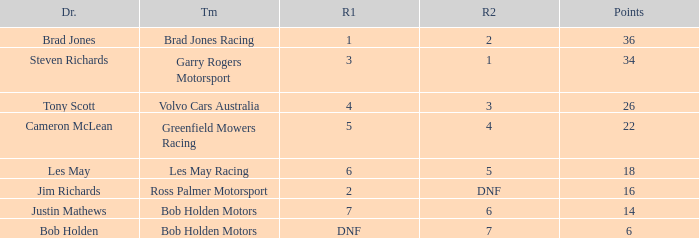Which driver for Greenfield Mowers Racing has fewer than 36 points? Cameron McLean. 